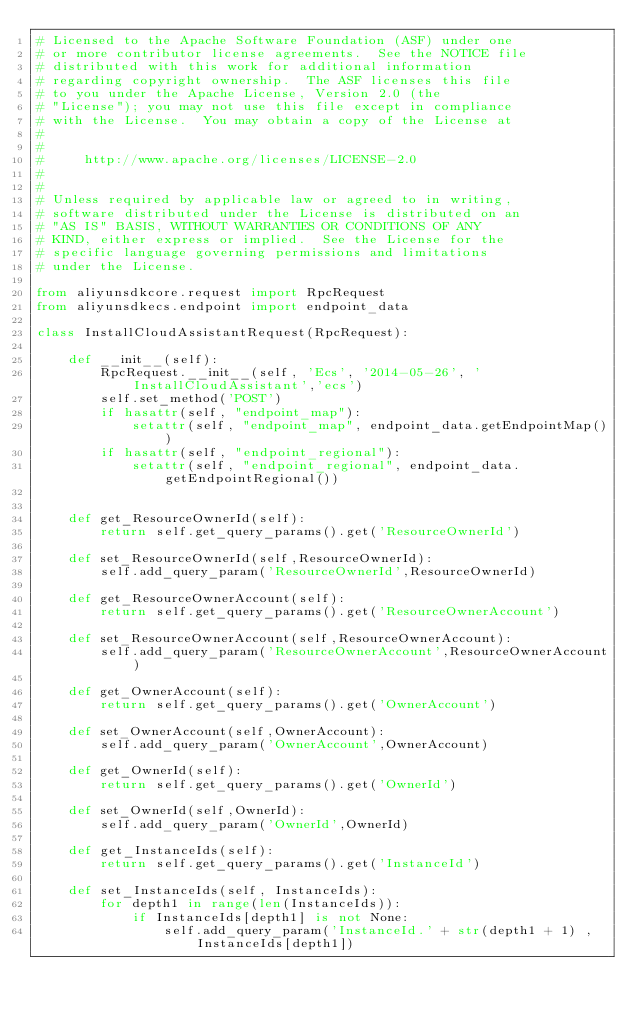<code> <loc_0><loc_0><loc_500><loc_500><_Python_># Licensed to the Apache Software Foundation (ASF) under one
# or more contributor license agreements.  See the NOTICE file
# distributed with this work for additional information
# regarding copyright ownership.  The ASF licenses this file
# to you under the Apache License, Version 2.0 (the
# "License"); you may not use this file except in compliance
# with the License.  You may obtain a copy of the License at
#
#
#     http://www.apache.org/licenses/LICENSE-2.0
#
#
# Unless required by applicable law or agreed to in writing,
# software distributed under the License is distributed on an
# "AS IS" BASIS, WITHOUT WARRANTIES OR CONDITIONS OF ANY
# KIND, either express or implied.  See the License for the
# specific language governing permissions and limitations
# under the License.

from aliyunsdkcore.request import RpcRequest
from aliyunsdkecs.endpoint import endpoint_data

class InstallCloudAssistantRequest(RpcRequest):

	def __init__(self):
		RpcRequest.__init__(self, 'Ecs', '2014-05-26', 'InstallCloudAssistant','ecs')
		self.set_method('POST')
		if hasattr(self, "endpoint_map"):
			setattr(self, "endpoint_map", endpoint_data.getEndpointMap())
		if hasattr(self, "endpoint_regional"):
			setattr(self, "endpoint_regional", endpoint_data.getEndpointRegional())


	def get_ResourceOwnerId(self):
		return self.get_query_params().get('ResourceOwnerId')

	def set_ResourceOwnerId(self,ResourceOwnerId):
		self.add_query_param('ResourceOwnerId',ResourceOwnerId)

	def get_ResourceOwnerAccount(self):
		return self.get_query_params().get('ResourceOwnerAccount')

	def set_ResourceOwnerAccount(self,ResourceOwnerAccount):
		self.add_query_param('ResourceOwnerAccount',ResourceOwnerAccount)

	def get_OwnerAccount(self):
		return self.get_query_params().get('OwnerAccount')

	def set_OwnerAccount(self,OwnerAccount):
		self.add_query_param('OwnerAccount',OwnerAccount)

	def get_OwnerId(self):
		return self.get_query_params().get('OwnerId')

	def set_OwnerId(self,OwnerId):
		self.add_query_param('OwnerId',OwnerId)

	def get_InstanceIds(self):
		return self.get_query_params().get('InstanceId')

	def set_InstanceIds(self, InstanceIds):
		for depth1 in range(len(InstanceIds)):
			if InstanceIds[depth1] is not None:
				self.add_query_param('InstanceId.' + str(depth1 + 1) , InstanceIds[depth1])</code> 